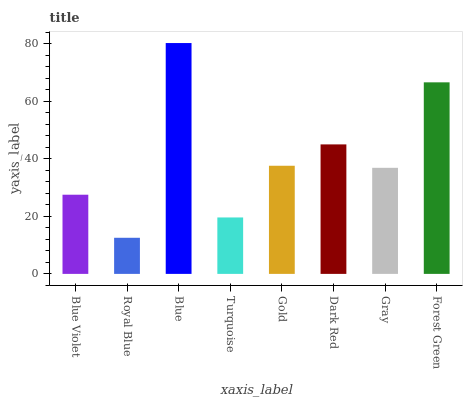Is Royal Blue the minimum?
Answer yes or no. Yes. Is Blue the maximum?
Answer yes or no. Yes. Is Blue the minimum?
Answer yes or no. No. Is Royal Blue the maximum?
Answer yes or no. No. Is Blue greater than Royal Blue?
Answer yes or no. Yes. Is Royal Blue less than Blue?
Answer yes or no. Yes. Is Royal Blue greater than Blue?
Answer yes or no. No. Is Blue less than Royal Blue?
Answer yes or no. No. Is Gold the high median?
Answer yes or no. Yes. Is Gray the low median?
Answer yes or no. Yes. Is Dark Red the high median?
Answer yes or no. No. Is Forest Green the low median?
Answer yes or no. No. 